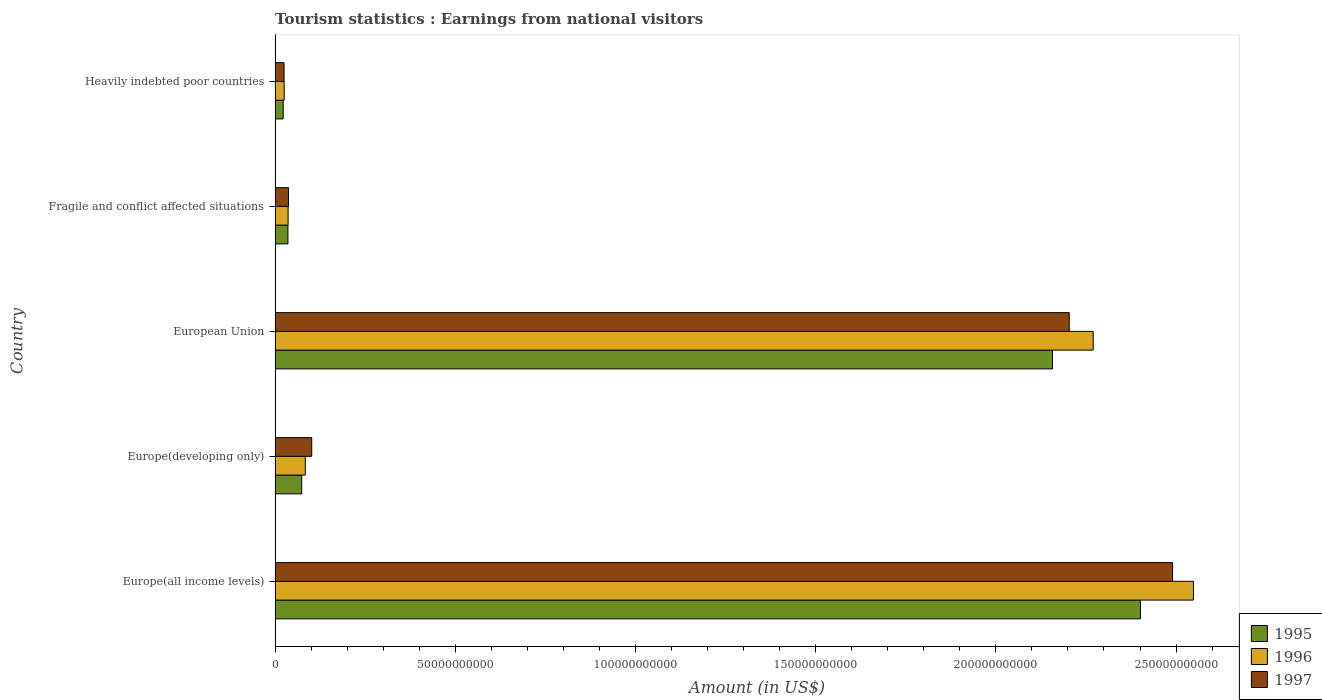How many different coloured bars are there?
Make the answer very short. 3. Are the number of bars per tick equal to the number of legend labels?
Ensure brevity in your answer.  Yes. Are the number of bars on each tick of the Y-axis equal?
Ensure brevity in your answer.  Yes. How many bars are there on the 1st tick from the bottom?
Ensure brevity in your answer.  3. What is the earnings from national visitors in 1996 in European Union?
Your answer should be compact. 2.27e+11. Across all countries, what is the maximum earnings from national visitors in 1995?
Give a very brief answer. 2.40e+11. Across all countries, what is the minimum earnings from national visitors in 1996?
Your answer should be very brief. 2.53e+09. In which country was the earnings from national visitors in 1995 maximum?
Offer a very short reply. Europe(all income levels). In which country was the earnings from national visitors in 1997 minimum?
Make the answer very short. Heavily indebted poor countries. What is the total earnings from national visitors in 1996 in the graph?
Keep it short and to the point. 4.96e+11. What is the difference between the earnings from national visitors in 1995 in European Union and that in Heavily indebted poor countries?
Provide a short and direct response. 2.13e+11. What is the difference between the earnings from national visitors in 1997 in Heavily indebted poor countries and the earnings from national visitors in 1995 in Europe(developing only)?
Ensure brevity in your answer.  -4.90e+09. What is the average earnings from national visitors in 1996 per country?
Ensure brevity in your answer.  9.93e+1. What is the difference between the earnings from national visitors in 1995 and earnings from national visitors in 1997 in European Union?
Provide a short and direct response. -4.65e+09. What is the ratio of the earnings from national visitors in 1996 in Europe(developing only) to that in Heavily indebted poor countries?
Keep it short and to the point. 3.32. What is the difference between the highest and the second highest earnings from national visitors in 1996?
Provide a short and direct response. 2.78e+1. What is the difference between the highest and the lowest earnings from national visitors in 1995?
Provide a short and direct response. 2.38e+11. What does the 1st bar from the top in Europe(all income levels) represents?
Make the answer very short. 1997. How many bars are there?
Ensure brevity in your answer.  15. Are all the bars in the graph horizontal?
Give a very brief answer. Yes. Does the graph contain any zero values?
Your answer should be compact. No. How many legend labels are there?
Your response must be concise. 3. How are the legend labels stacked?
Offer a very short reply. Vertical. What is the title of the graph?
Keep it short and to the point. Tourism statistics : Earnings from national visitors. What is the label or title of the Y-axis?
Provide a succinct answer. Country. What is the Amount (in US$) of 1995 in Europe(all income levels)?
Your response must be concise. 2.40e+11. What is the Amount (in US$) of 1996 in Europe(all income levels)?
Offer a terse response. 2.55e+11. What is the Amount (in US$) of 1997 in Europe(all income levels)?
Your answer should be very brief. 2.49e+11. What is the Amount (in US$) in 1995 in Europe(developing only)?
Provide a short and direct response. 7.39e+09. What is the Amount (in US$) of 1996 in Europe(developing only)?
Offer a very short reply. 8.39e+09. What is the Amount (in US$) in 1997 in Europe(developing only)?
Offer a very short reply. 1.02e+1. What is the Amount (in US$) in 1995 in European Union?
Ensure brevity in your answer.  2.16e+11. What is the Amount (in US$) of 1996 in European Union?
Offer a terse response. 2.27e+11. What is the Amount (in US$) of 1997 in European Union?
Provide a short and direct response. 2.20e+11. What is the Amount (in US$) of 1995 in Fragile and conflict affected situations?
Provide a short and direct response. 3.57e+09. What is the Amount (in US$) of 1996 in Fragile and conflict affected situations?
Offer a terse response. 3.61e+09. What is the Amount (in US$) in 1997 in Fragile and conflict affected situations?
Your response must be concise. 3.72e+09. What is the Amount (in US$) in 1995 in Heavily indebted poor countries?
Offer a very short reply. 2.25e+09. What is the Amount (in US$) in 1996 in Heavily indebted poor countries?
Provide a succinct answer. 2.53e+09. What is the Amount (in US$) of 1997 in Heavily indebted poor countries?
Your response must be concise. 2.49e+09. Across all countries, what is the maximum Amount (in US$) in 1995?
Your response must be concise. 2.40e+11. Across all countries, what is the maximum Amount (in US$) in 1996?
Provide a succinct answer. 2.55e+11. Across all countries, what is the maximum Amount (in US$) of 1997?
Your response must be concise. 2.49e+11. Across all countries, what is the minimum Amount (in US$) in 1995?
Offer a terse response. 2.25e+09. Across all countries, what is the minimum Amount (in US$) of 1996?
Keep it short and to the point. 2.53e+09. Across all countries, what is the minimum Amount (in US$) of 1997?
Provide a succinct answer. 2.49e+09. What is the total Amount (in US$) of 1995 in the graph?
Give a very brief answer. 4.69e+11. What is the total Amount (in US$) in 1996 in the graph?
Ensure brevity in your answer.  4.96e+11. What is the total Amount (in US$) in 1997 in the graph?
Make the answer very short. 4.86e+11. What is the difference between the Amount (in US$) of 1995 in Europe(all income levels) and that in Europe(developing only)?
Your response must be concise. 2.33e+11. What is the difference between the Amount (in US$) in 1996 in Europe(all income levels) and that in Europe(developing only)?
Make the answer very short. 2.46e+11. What is the difference between the Amount (in US$) in 1997 in Europe(all income levels) and that in Europe(developing only)?
Make the answer very short. 2.39e+11. What is the difference between the Amount (in US$) in 1995 in Europe(all income levels) and that in European Union?
Your response must be concise. 2.44e+1. What is the difference between the Amount (in US$) in 1996 in Europe(all income levels) and that in European Union?
Provide a short and direct response. 2.78e+1. What is the difference between the Amount (in US$) in 1997 in Europe(all income levels) and that in European Union?
Provide a short and direct response. 2.87e+1. What is the difference between the Amount (in US$) of 1995 in Europe(all income levels) and that in Fragile and conflict affected situations?
Offer a very short reply. 2.37e+11. What is the difference between the Amount (in US$) in 1996 in Europe(all income levels) and that in Fragile and conflict affected situations?
Keep it short and to the point. 2.51e+11. What is the difference between the Amount (in US$) of 1997 in Europe(all income levels) and that in Fragile and conflict affected situations?
Your answer should be very brief. 2.45e+11. What is the difference between the Amount (in US$) of 1995 in Europe(all income levels) and that in Heavily indebted poor countries?
Your answer should be very brief. 2.38e+11. What is the difference between the Amount (in US$) in 1996 in Europe(all income levels) and that in Heavily indebted poor countries?
Offer a very short reply. 2.52e+11. What is the difference between the Amount (in US$) of 1997 in Europe(all income levels) and that in Heavily indebted poor countries?
Keep it short and to the point. 2.47e+11. What is the difference between the Amount (in US$) in 1995 in Europe(developing only) and that in European Union?
Your answer should be compact. -2.08e+11. What is the difference between the Amount (in US$) in 1996 in Europe(developing only) and that in European Union?
Your response must be concise. -2.19e+11. What is the difference between the Amount (in US$) of 1997 in Europe(developing only) and that in European Union?
Offer a very short reply. -2.10e+11. What is the difference between the Amount (in US$) of 1995 in Europe(developing only) and that in Fragile and conflict affected situations?
Provide a succinct answer. 3.83e+09. What is the difference between the Amount (in US$) in 1996 in Europe(developing only) and that in Fragile and conflict affected situations?
Provide a short and direct response. 4.78e+09. What is the difference between the Amount (in US$) in 1997 in Europe(developing only) and that in Fragile and conflict affected situations?
Offer a terse response. 6.44e+09. What is the difference between the Amount (in US$) in 1995 in Europe(developing only) and that in Heavily indebted poor countries?
Offer a very short reply. 5.14e+09. What is the difference between the Amount (in US$) in 1996 in Europe(developing only) and that in Heavily indebted poor countries?
Provide a short and direct response. 5.86e+09. What is the difference between the Amount (in US$) in 1997 in Europe(developing only) and that in Heavily indebted poor countries?
Your answer should be compact. 7.67e+09. What is the difference between the Amount (in US$) of 1995 in European Union and that in Fragile and conflict affected situations?
Offer a terse response. 2.12e+11. What is the difference between the Amount (in US$) in 1996 in European Union and that in Fragile and conflict affected situations?
Keep it short and to the point. 2.23e+11. What is the difference between the Amount (in US$) in 1997 in European Union and that in Fragile and conflict affected situations?
Provide a short and direct response. 2.17e+11. What is the difference between the Amount (in US$) in 1995 in European Union and that in Heavily indebted poor countries?
Provide a succinct answer. 2.13e+11. What is the difference between the Amount (in US$) of 1996 in European Union and that in Heavily indebted poor countries?
Provide a short and direct response. 2.24e+11. What is the difference between the Amount (in US$) of 1997 in European Union and that in Heavily indebted poor countries?
Your response must be concise. 2.18e+11. What is the difference between the Amount (in US$) in 1995 in Fragile and conflict affected situations and that in Heavily indebted poor countries?
Give a very brief answer. 1.32e+09. What is the difference between the Amount (in US$) in 1996 in Fragile and conflict affected situations and that in Heavily indebted poor countries?
Offer a very short reply. 1.08e+09. What is the difference between the Amount (in US$) of 1997 in Fragile and conflict affected situations and that in Heavily indebted poor countries?
Offer a terse response. 1.23e+09. What is the difference between the Amount (in US$) in 1995 in Europe(all income levels) and the Amount (in US$) in 1996 in Europe(developing only)?
Your answer should be very brief. 2.32e+11. What is the difference between the Amount (in US$) in 1995 in Europe(all income levels) and the Amount (in US$) in 1997 in Europe(developing only)?
Offer a very short reply. 2.30e+11. What is the difference between the Amount (in US$) of 1996 in Europe(all income levels) and the Amount (in US$) of 1997 in Europe(developing only)?
Offer a terse response. 2.45e+11. What is the difference between the Amount (in US$) of 1995 in Europe(all income levels) and the Amount (in US$) of 1996 in European Union?
Your answer should be very brief. 1.31e+1. What is the difference between the Amount (in US$) in 1995 in Europe(all income levels) and the Amount (in US$) in 1997 in European Union?
Offer a very short reply. 1.97e+1. What is the difference between the Amount (in US$) in 1996 in Europe(all income levels) and the Amount (in US$) in 1997 in European Union?
Offer a very short reply. 3.45e+1. What is the difference between the Amount (in US$) of 1995 in Europe(all income levels) and the Amount (in US$) of 1996 in Fragile and conflict affected situations?
Provide a short and direct response. 2.37e+11. What is the difference between the Amount (in US$) of 1995 in Europe(all income levels) and the Amount (in US$) of 1997 in Fragile and conflict affected situations?
Ensure brevity in your answer.  2.36e+11. What is the difference between the Amount (in US$) in 1996 in Europe(all income levels) and the Amount (in US$) in 1997 in Fragile and conflict affected situations?
Your response must be concise. 2.51e+11. What is the difference between the Amount (in US$) in 1995 in Europe(all income levels) and the Amount (in US$) in 1996 in Heavily indebted poor countries?
Offer a terse response. 2.38e+11. What is the difference between the Amount (in US$) in 1995 in Europe(all income levels) and the Amount (in US$) in 1997 in Heavily indebted poor countries?
Give a very brief answer. 2.38e+11. What is the difference between the Amount (in US$) in 1996 in Europe(all income levels) and the Amount (in US$) in 1997 in Heavily indebted poor countries?
Keep it short and to the point. 2.52e+11. What is the difference between the Amount (in US$) of 1995 in Europe(developing only) and the Amount (in US$) of 1996 in European Union?
Ensure brevity in your answer.  -2.20e+11. What is the difference between the Amount (in US$) of 1995 in Europe(developing only) and the Amount (in US$) of 1997 in European Union?
Keep it short and to the point. -2.13e+11. What is the difference between the Amount (in US$) in 1996 in Europe(developing only) and the Amount (in US$) in 1997 in European Union?
Your response must be concise. -2.12e+11. What is the difference between the Amount (in US$) of 1995 in Europe(developing only) and the Amount (in US$) of 1996 in Fragile and conflict affected situations?
Ensure brevity in your answer.  3.78e+09. What is the difference between the Amount (in US$) of 1995 in Europe(developing only) and the Amount (in US$) of 1997 in Fragile and conflict affected situations?
Provide a short and direct response. 3.67e+09. What is the difference between the Amount (in US$) in 1996 in Europe(developing only) and the Amount (in US$) in 1997 in Fragile and conflict affected situations?
Provide a short and direct response. 4.67e+09. What is the difference between the Amount (in US$) in 1995 in Europe(developing only) and the Amount (in US$) in 1996 in Heavily indebted poor countries?
Provide a short and direct response. 4.87e+09. What is the difference between the Amount (in US$) in 1995 in Europe(developing only) and the Amount (in US$) in 1997 in Heavily indebted poor countries?
Your answer should be compact. 4.90e+09. What is the difference between the Amount (in US$) of 1996 in Europe(developing only) and the Amount (in US$) of 1997 in Heavily indebted poor countries?
Offer a terse response. 5.90e+09. What is the difference between the Amount (in US$) in 1995 in European Union and the Amount (in US$) in 1996 in Fragile and conflict affected situations?
Ensure brevity in your answer.  2.12e+11. What is the difference between the Amount (in US$) of 1995 in European Union and the Amount (in US$) of 1997 in Fragile and conflict affected situations?
Make the answer very short. 2.12e+11. What is the difference between the Amount (in US$) of 1996 in European Union and the Amount (in US$) of 1997 in Fragile and conflict affected situations?
Your answer should be very brief. 2.23e+11. What is the difference between the Amount (in US$) of 1995 in European Union and the Amount (in US$) of 1996 in Heavily indebted poor countries?
Provide a short and direct response. 2.13e+11. What is the difference between the Amount (in US$) of 1995 in European Union and the Amount (in US$) of 1997 in Heavily indebted poor countries?
Your answer should be very brief. 2.13e+11. What is the difference between the Amount (in US$) in 1996 in European Union and the Amount (in US$) in 1997 in Heavily indebted poor countries?
Offer a terse response. 2.25e+11. What is the difference between the Amount (in US$) of 1995 in Fragile and conflict affected situations and the Amount (in US$) of 1996 in Heavily indebted poor countries?
Ensure brevity in your answer.  1.04e+09. What is the difference between the Amount (in US$) in 1995 in Fragile and conflict affected situations and the Amount (in US$) in 1997 in Heavily indebted poor countries?
Keep it short and to the point. 1.07e+09. What is the difference between the Amount (in US$) in 1996 in Fragile and conflict affected situations and the Amount (in US$) in 1997 in Heavily indebted poor countries?
Your answer should be very brief. 1.12e+09. What is the average Amount (in US$) in 1995 per country?
Ensure brevity in your answer.  9.38e+1. What is the average Amount (in US$) in 1996 per country?
Offer a very short reply. 9.93e+1. What is the average Amount (in US$) of 1997 per country?
Your response must be concise. 9.72e+1. What is the difference between the Amount (in US$) in 1995 and Amount (in US$) in 1996 in Europe(all income levels)?
Your answer should be compact. -1.47e+1. What is the difference between the Amount (in US$) of 1995 and Amount (in US$) of 1997 in Europe(all income levels)?
Offer a very short reply. -8.92e+09. What is the difference between the Amount (in US$) of 1996 and Amount (in US$) of 1997 in Europe(all income levels)?
Give a very brief answer. 5.79e+09. What is the difference between the Amount (in US$) in 1995 and Amount (in US$) in 1996 in Europe(developing only)?
Your answer should be compact. -9.97e+08. What is the difference between the Amount (in US$) of 1995 and Amount (in US$) of 1997 in Europe(developing only)?
Keep it short and to the point. -2.77e+09. What is the difference between the Amount (in US$) of 1996 and Amount (in US$) of 1997 in Europe(developing only)?
Make the answer very short. -1.77e+09. What is the difference between the Amount (in US$) in 1995 and Amount (in US$) in 1996 in European Union?
Provide a short and direct response. -1.13e+1. What is the difference between the Amount (in US$) of 1995 and Amount (in US$) of 1997 in European Union?
Offer a terse response. -4.65e+09. What is the difference between the Amount (in US$) in 1996 and Amount (in US$) in 1997 in European Union?
Give a very brief answer. 6.65e+09. What is the difference between the Amount (in US$) in 1995 and Amount (in US$) in 1996 in Fragile and conflict affected situations?
Provide a short and direct response. -4.22e+07. What is the difference between the Amount (in US$) in 1995 and Amount (in US$) in 1997 in Fragile and conflict affected situations?
Give a very brief answer. -1.56e+08. What is the difference between the Amount (in US$) of 1996 and Amount (in US$) of 1997 in Fragile and conflict affected situations?
Provide a short and direct response. -1.13e+08. What is the difference between the Amount (in US$) of 1995 and Amount (in US$) of 1996 in Heavily indebted poor countries?
Offer a very short reply. -2.74e+08. What is the difference between the Amount (in US$) in 1995 and Amount (in US$) in 1997 in Heavily indebted poor countries?
Keep it short and to the point. -2.42e+08. What is the difference between the Amount (in US$) of 1996 and Amount (in US$) of 1997 in Heavily indebted poor countries?
Your answer should be very brief. 3.21e+07. What is the ratio of the Amount (in US$) of 1995 in Europe(all income levels) to that in Europe(developing only)?
Your answer should be compact. 32.48. What is the ratio of the Amount (in US$) in 1996 in Europe(all income levels) to that in Europe(developing only)?
Your answer should be very brief. 30.37. What is the ratio of the Amount (in US$) of 1997 in Europe(all income levels) to that in Europe(developing only)?
Your answer should be compact. 24.51. What is the ratio of the Amount (in US$) of 1995 in Europe(all income levels) to that in European Union?
Make the answer very short. 1.11. What is the ratio of the Amount (in US$) in 1996 in Europe(all income levels) to that in European Union?
Offer a terse response. 1.12. What is the ratio of the Amount (in US$) of 1997 in Europe(all income levels) to that in European Union?
Give a very brief answer. 1.13. What is the ratio of the Amount (in US$) in 1995 in Europe(all income levels) to that in Fragile and conflict affected situations?
Your answer should be very brief. 67.32. What is the ratio of the Amount (in US$) in 1996 in Europe(all income levels) to that in Fragile and conflict affected situations?
Provide a succinct answer. 70.61. What is the ratio of the Amount (in US$) of 1997 in Europe(all income levels) to that in Fragile and conflict affected situations?
Keep it short and to the point. 66.9. What is the ratio of the Amount (in US$) in 1995 in Europe(all income levels) to that in Heavily indebted poor countries?
Make the answer very short. 106.66. What is the ratio of the Amount (in US$) of 1996 in Europe(all income levels) to that in Heavily indebted poor countries?
Keep it short and to the point. 100.9. What is the ratio of the Amount (in US$) of 1997 in Europe(all income levels) to that in Heavily indebted poor countries?
Give a very brief answer. 99.87. What is the ratio of the Amount (in US$) in 1995 in Europe(developing only) to that in European Union?
Your response must be concise. 0.03. What is the ratio of the Amount (in US$) of 1996 in Europe(developing only) to that in European Union?
Give a very brief answer. 0.04. What is the ratio of the Amount (in US$) of 1997 in Europe(developing only) to that in European Union?
Your response must be concise. 0.05. What is the ratio of the Amount (in US$) in 1995 in Europe(developing only) to that in Fragile and conflict affected situations?
Offer a terse response. 2.07. What is the ratio of the Amount (in US$) of 1996 in Europe(developing only) to that in Fragile and conflict affected situations?
Your answer should be compact. 2.32. What is the ratio of the Amount (in US$) in 1997 in Europe(developing only) to that in Fragile and conflict affected situations?
Make the answer very short. 2.73. What is the ratio of the Amount (in US$) of 1995 in Europe(developing only) to that in Heavily indebted poor countries?
Offer a very short reply. 3.28. What is the ratio of the Amount (in US$) of 1996 in Europe(developing only) to that in Heavily indebted poor countries?
Your response must be concise. 3.32. What is the ratio of the Amount (in US$) in 1997 in Europe(developing only) to that in Heavily indebted poor countries?
Provide a succinct answer. 4.08. What is the ratio of the Amount (in US$) in 1995 in European Union to that in Fragile and conflict affected situations?
Provide a short and direct response. 60.48. What is the ratio of the Amount (in US$) of 1996 in European Union to that in Fragile and conflict affected situations?
Give a very brief answer. 62.9. What is the ratio of the Amount (in US$) in 1997 in European Union to that in Fragile and conflict affected situations?
Keep it short and to the point. 59.2. What is the ratio of the Amount (in US$) of 1995 in European Union to that in Heavily indebted poor countries?
Provide a short and direct response. 95.82. What is the ratio of the Amount (in US$) of 1996 in European Union to that in Heavily indebted poor countries?
Ensure brevity in your answer.  89.88. What is the ratio of the Amount (in US$) in 1997 in European Union to that in Heavily indebted poor countries?
Offer a terse response. 88.38. What is the ratio of the Amount (in US$) of 1995 in Fragile and conflict affected situations to that in Heavily indebted poor countries?
Your response must be concise. 1.58. What is the ratio of the Amount (in US$) of 1996 in Fragile and conflict affected situations to that in Heavily indebted poor countries?
Keep it short and to the point. 1.43. What is the ratio of the Amount (in US$) in 1997 in Fragile and conflict affected situations to that in Heavily indebted poor countries?
Provide a succinct answer. 1.49. What is the difference between the highest and the second highest Amount (in US$) of 1995?
Give a very brief answer. 2.44e+1. What is the difference between the highest and the second highest Amount (in US$) in 1996?
Keep it short and to the point. 2.78e+1. What is the difference between the highest and the second highest Amount (in US$) of 1997?
Ensure brevity in your answer.  2.87e+1. What is the difference between the highest and the lowest Amount (in US$) in 1995?
Provide a short and direct response. 2.38e+11. What is the difference between the highest and the lowest Amount (in US$) of 1996?
Give a very brief answer. 2.52e+11. What is the difference between the highest and the lowest Amount (in US$) in 1997?
Make the answer very short. 2.47e+11. 